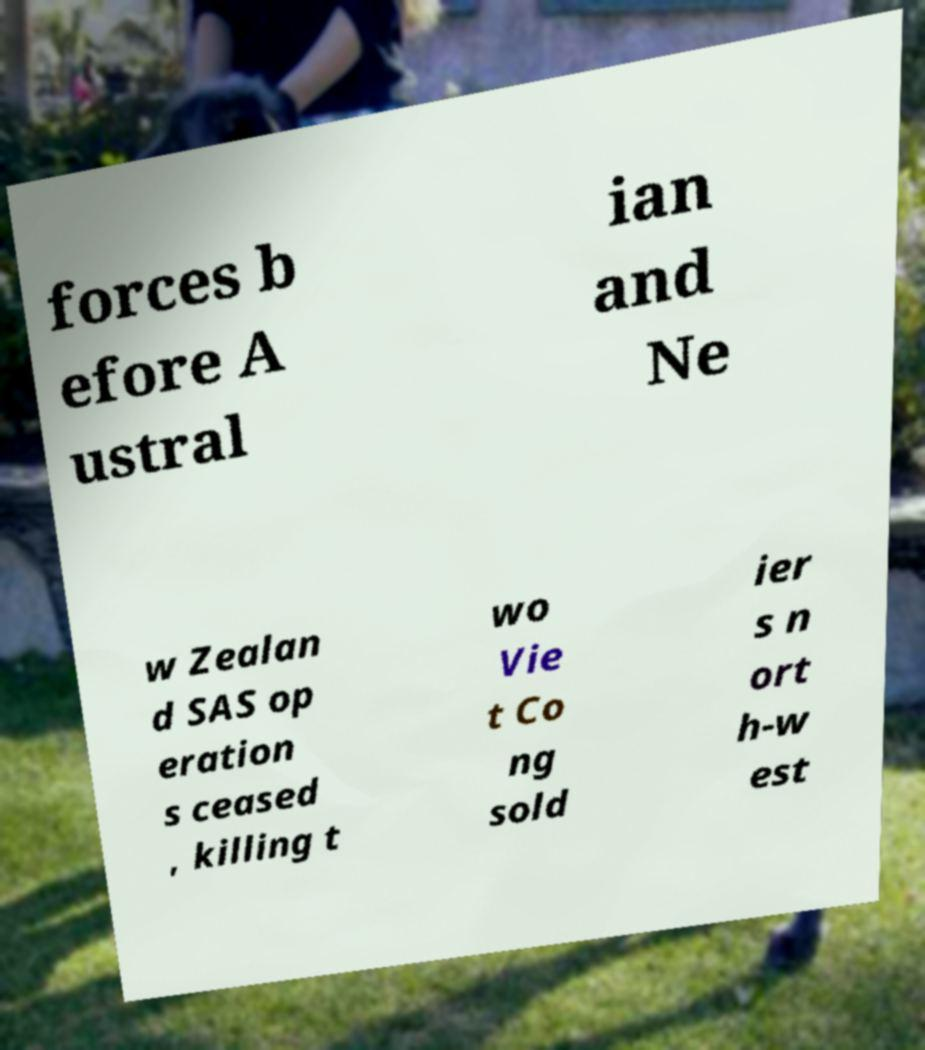There's text embedded in this image that I need extracted. Can you transcribe it verbatim? forces b efore A ustral ian and Ne w Zealan d SAS op eration s ceased , killing t wo Vie t Co ng sold ier s n ort h-w est 